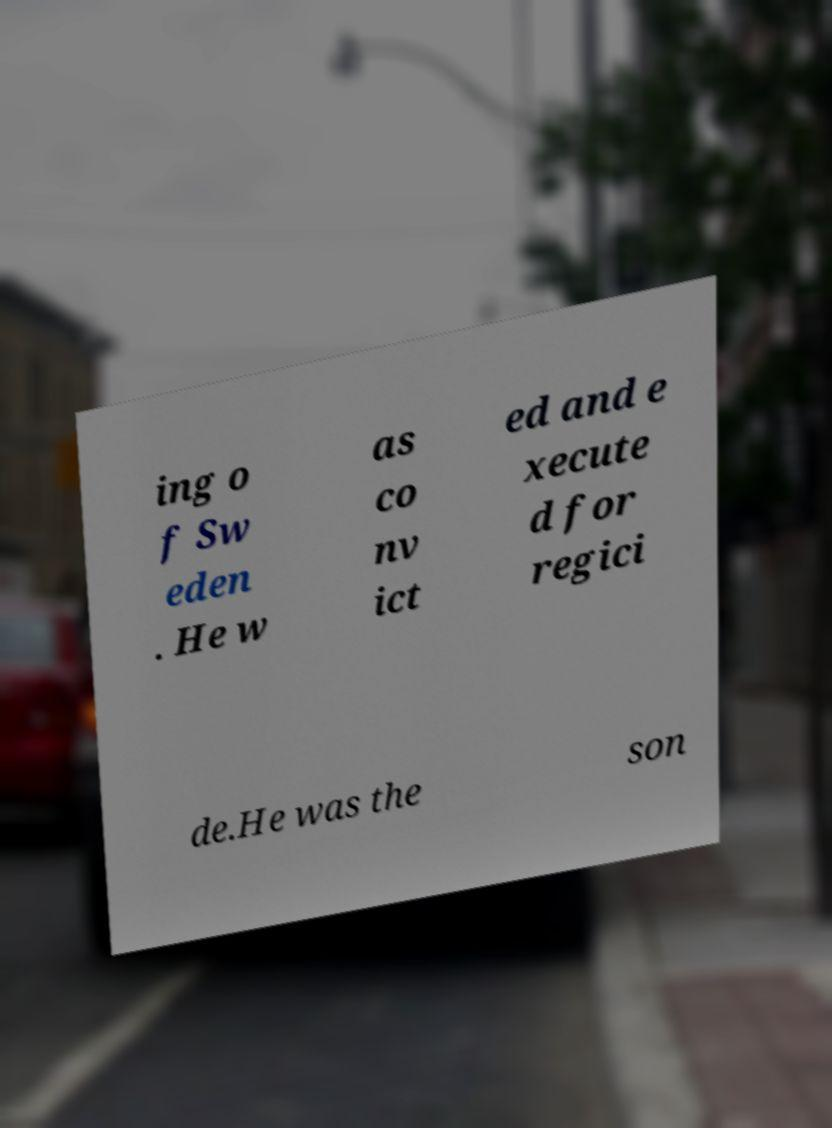I need the written content from this picture converted into text. Can you do that? ing o f Sw eden . He w as co nv ict ed and e xecute d for regici de.He was the son 